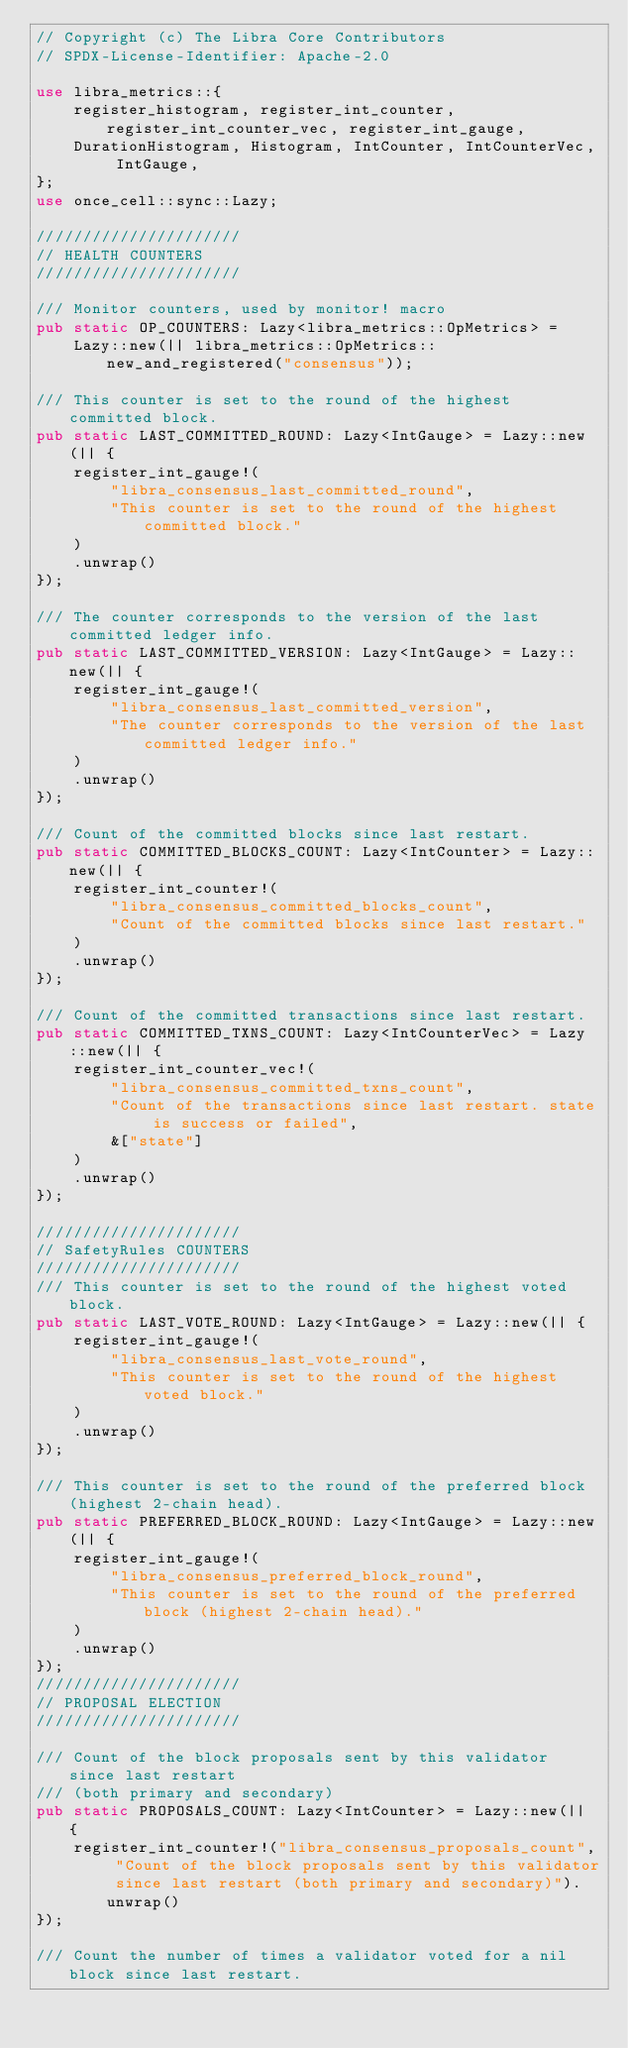<code> <loc_0><loc_0><loc_500><loc_500><_Rust_>// Copyright (c) The Libra Core Contributors
// SPDX-License-Identifier: Apache-2.0

use libra_metrics::{
    register_histogram, register_int_counter, register_int_counter_vec, register_int_gauge,
    DurationHistogram, Histogram, IntCounter, IntCounterVec, IntGauge,
};
use once_cell::sync::Lazy;

//////////////////////
// HEALTH COUNTERS
//////////////////////

/// Monitor counters, used by monitor! macro
pub static OP_COUNTERS: Lazy<libra_metrics::OpMetrics> =
    Lazy::new(|| libra_metrics::OpMetrics::new_and_registered("consensus"));

/// This counter is set to the round of the highest committed block.
pub static LAST_COMMITTED_ROUND: Lazy<IntGauge> = Lazy::new(|| {
    register_int_gauge!(
        "libra_consensus_last_committed_round",
        "This counter is set to the round of the highest committed block."
    )
    .unwrap()
});

/// The counter corresponds to the version of the last committed ledger info.
pub static LAST_COMMITTED_VERSION: Lazy<IntGauge> = Lazy::new(|| {
    register_int_gauge!(
        "libra_consensus_last_committed_version",
        "The counter corresponds to the version of the last committed ledger info."
    )
    .unwrap()
});

/// Count of the committed blocks since last restart.
pub static COMMITTED_BLOCKS_COUNT: Lazy<IntCounter> = Lazy::new(|| {
    register_int_counter!(
        "libra_consensus_committed_blocks_count",
        "Count of the committed blocks since last restart."
    )
    .unwrap()
});

/// Count of the committed transactions since last restart.
pub static COMMITTED_TXNS_COUNT: Lazy<IntCounterVec> = Lazy::new(|| {
    register_int_counter_vec!(
        "libra_consensus_committed_txns_count",
        "Count of the transactions since last restart. state is success or failed",
        &["state"]
    )
    .unwrap()
});

//////////////////////
// SafetyRules COUNTERS
//////////////////////
/// This counter is set to the round of the highest voted block.
pub static LAST_VOTE_ROUND: Lazy<IntGauge> = Lazy::new(|| {
    register_int_gauge!(
        "libra_consensus_last_vote_round",
        "This counter is set to the round of the highest voted block."
    )
    .unwrap()
});

/// This counter is set to the round of the preferred block (highest 2-chain head).
pub static PREFERRED_BLOCK_ROUND: Lazy<IntGauge> = Lazy::new(|| {
    register_int_gauge!(
        "libra_consensus_preferred_block_round",
        "This counter is set to the round of the preferred block (highest 2-chain head)."
    )
    .unwrap()
});
//////////////////////
// PROPOSAL ELECTION
//////////////////////

/// Count of the block proposals sent by this validator since last restart
/// (both primary and secondary)
pub static PROPOSALS_COUNT: Lazy<IntCounter> = Lazy::new(|| {
    register_int_counter!("libra_consensus_proposals_count", "Count of the block proposals sent by this validator since last restart (both primary and secondary)").unwrap()
});

/// Count the number of times a validator voted for a nil block since last restart.</code> 